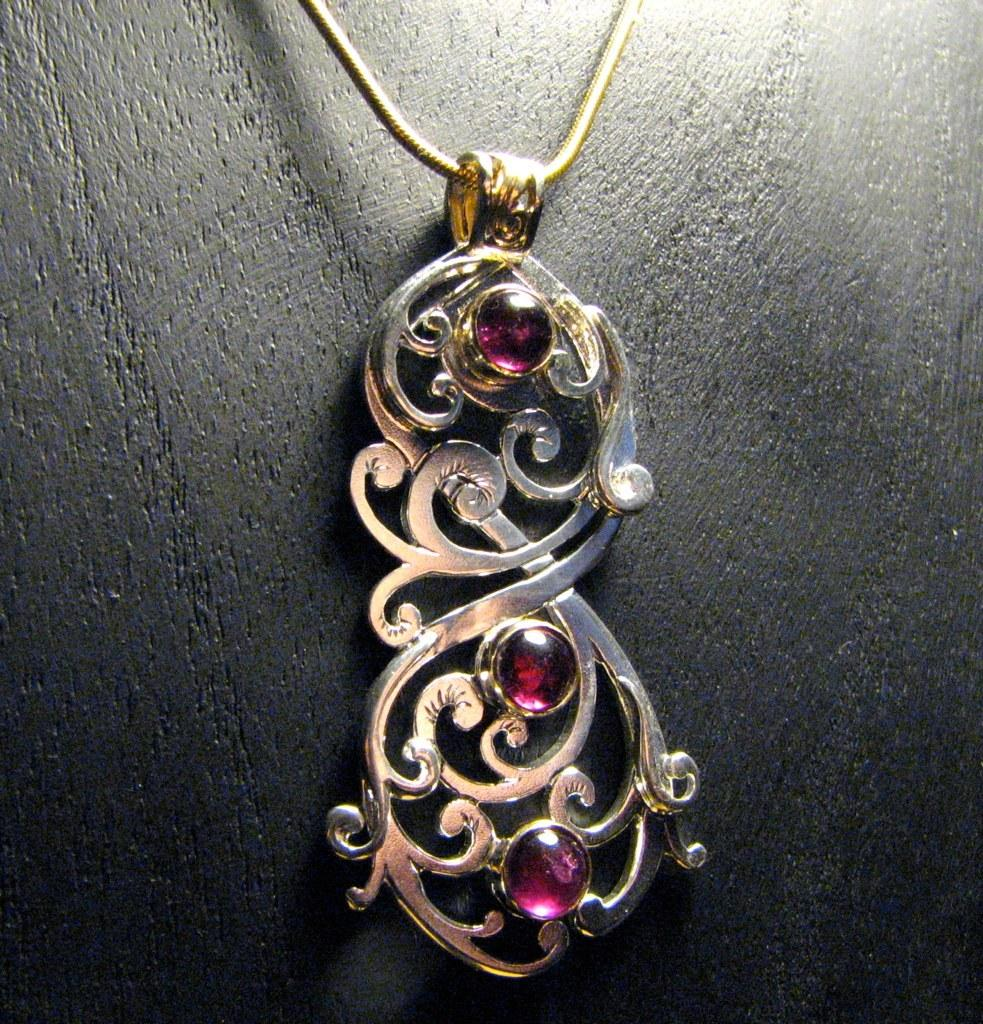What is the main subject of the image? There is a jewelry ornament in the middle of the image. Can you describe any other elements in the image? There is a chain visible at the top of the image. What type of poison is being offered by the jewelry ornament in the image? There is no mention of poison or any offer in the image; it features a jewelry ornament and a chain. 